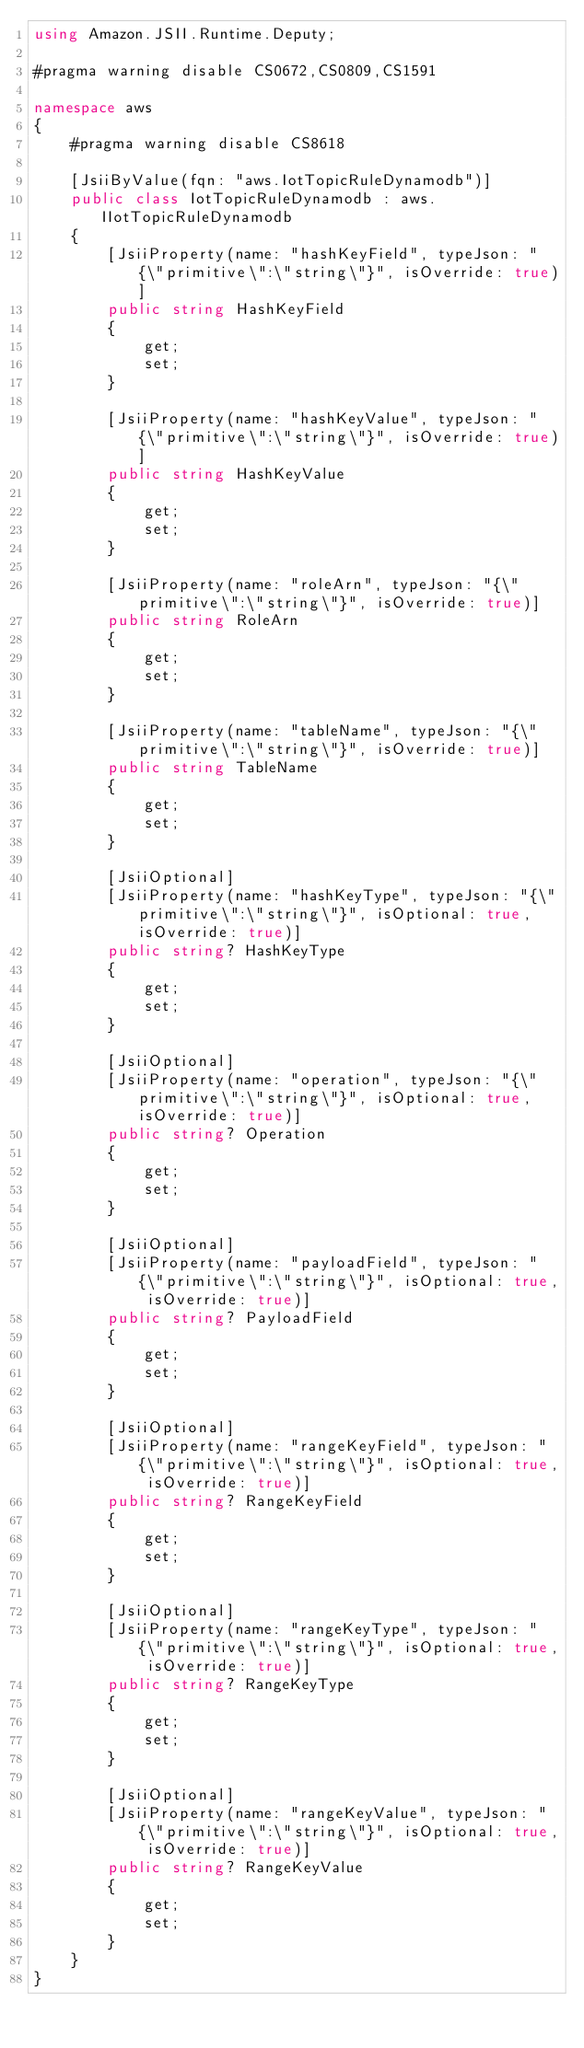<code> <loc_0><loc_0><loc_500><loc_500><_C#_>using Amazon.JSII.Runtime.Deputy;

#pragma warning disable CS0672,CS0809,CS1591

namespace aws
{
    #pragma warning disable CS8618

    [JsiiByValue(fqn: "aws.IotTopicRuleDynamodb")]
    public class IotTopicRuleDynamodb : aws.IIotTopicRuleDynamodb
    {
        [JsiiProperty(name: "hashKeyField", typeJson: "{\"primitive\":\"string\"}", isOverride: true)]
        public string HashKeyField
        {
            get;
            set;
        }

        [JsiiProperty(name: "hashKeyValue", typeJson: "{\"primitive\":\"string\"}", isOverride: true)]
        public string HashKeyValue
        {
            get;
            set;
        }

        [JsiiProperty(name: "roleArn", typeJson: "{\"primitive\":\"string\"}", isOverride: true)]
        public string RoleArn
        {
            get;
            set;
        }

        [JsiiProperty(name: "tableName", typeJson: "{\"primitive\":\"string\"}", isOverride: true)]
        public string TableName
        {
            get;
            set;
        }

        [JsiiOptional]
        [JsiiProperty(name: "hashKeyType", typeJson: "{\"primitive\":\"string\"}", isOptional: true, isOverride: true)]
        public string? HashKeyType
        {
            get;
            set;
        }

        [JsiiOptional]
        [JsiiProperty(name: "operation", typeJson: "{\"primitive\":\"string\"}", isOptional: true, isOverride: true)]
        public string? Operation
        {
            get;
            set;
        }

        [JsiiOptional]
        [JsiiProperty(name: "payloadField", typeJson: "{\"primitive\":\"string\"}", isOptional: true, isOverride: true)]
        public string? PayloadField
        {
            get;
            set;
        }

        [JsiiOptional]
        [JsiiProperty(name: "rangeKeyField", typeJson: "{\"primitive\":\"string\"}", isOptional: true, isOverride: true)]
        public string? RangeKeyField
        {
            get;
            set;
        }

        [JsiiOptional]
        [JsiiProperty(name: "rangeKeyType", typeJson: "{\"primitive\":\"string\"}", isOptional: true, isOverride: true)]
        public string? RangeKeyType
        {
            get;
            set;
        }

        [JsiiOptional]
        [JsiiProperty(name: "rangeKeyValue", typeJson: "{\"primitive\":\"string\"}", isOptional: true, isOverride: true)]
        public string? RangeKeyValue
        {
            get;
            set;
        }
    }
}
</code> 